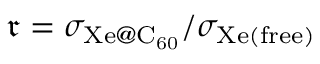<formula> <loc_0><loc_0><loc_500><loc_500>\mathfrak { r } = { \sigma _ { X e C _ { 6 0 } } } / { \sigma _ { X e ( f r e e ) } }</formula> 